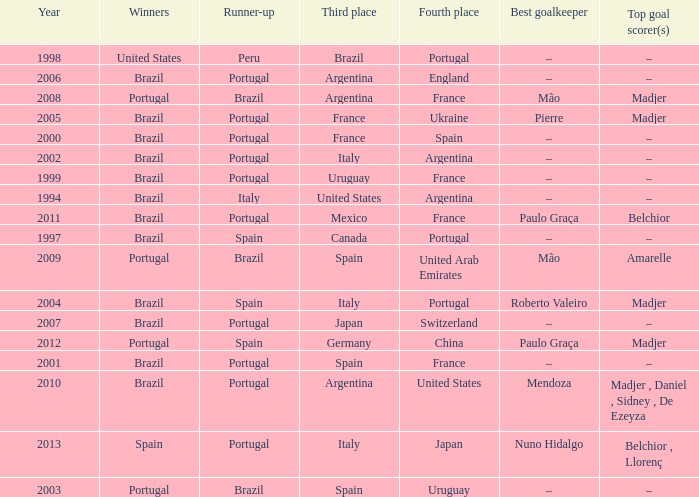What year was the runner-up Portugal with Italy in third place, and the gold keeper Nuno Hidalgo? 2013.0. 